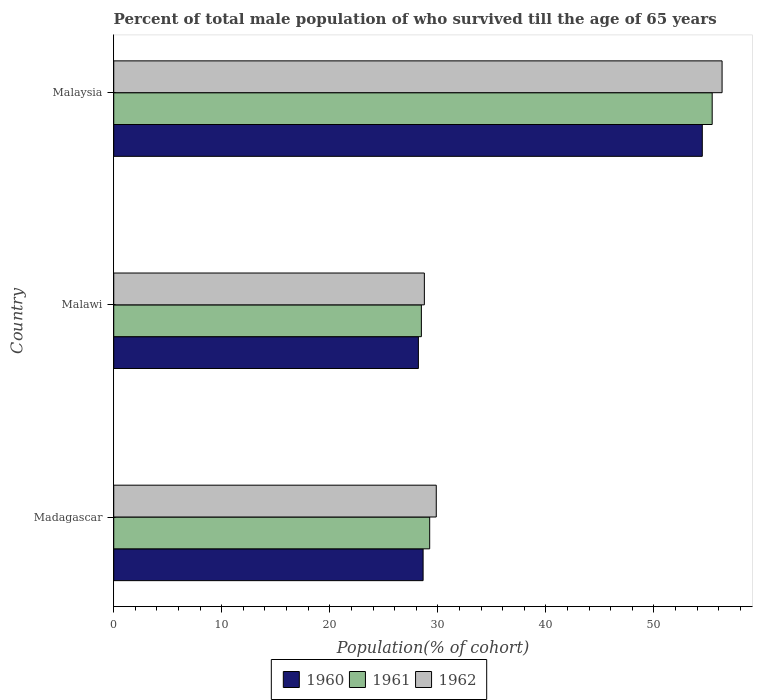How many different coloured bars are there?
Make the answer very short. 3. Are the number of bars on each tick of the Y-axis equal?
Provide a short and direct response. Yes. What is the label of the 3rd group of bars from the top?
Give a very brief answer. Madagascar. What is the percentage of total male population who survived till the age of 65 years in 1961 in Malaysia?
Ensure brevity in your answer.  55.4. Across all countries, what is the maximum percentage of total male population who survived till the age of 65 years in 1962?
Your response must be concise. 56.31. Across all countries, what is the minimum percentage of total male population who survived till the age of 65 years in 1960?
Your answer should be compact. 28.2. In which country was the percentage of total male population who survived till the age of 65 years in 1961 maximum?
Offer a terse response. Malaysia. In which country was the percentage of total male population who survived till the age of 65 years in 1961 minimum?
Your answer should be compact. Malawi. What is the total percentage of total male population who survived till the age of 65 years in 1960 in the graph?
Your answer should be compact. 111.32. What is the difference between the percentage of total male population who survived till the age of 65 years in 1961 in Malawi and that in Malaysia?
Offer a very short reply. -26.92. What is the difference between the percentage of total male population who survived till the age of 65 years in 1960 in Malawi and the percentage of total male population who survived till the age of 65 years in 1962 in Madagascar?
Keep it short and to the point. -1.65. What is the average percentage of total male population who survived till the age of 65 years in 1962 per country?
Provide a succinct answer. 38.31. What is the difference between the percentage of total male population who survived till the age of 65 years in 1960 and percentage of total male population who survived till the age of 65 years in 1961 in Madagascar?
Provide a short and direct response. -0.61. In how many countries, is the percentage of total male population who survived till the age of 65 years in 1962 greater than 12 %?
Give a very brief answer. 3. What is the ratio of the percentage of total male population who survived till the age of 65 years in 1960 in Madagascar to that in Malaysia?
Your response must be concise. 0.53. Is the percentage of total male population who survived till the age of 65 years in 1962 in Malawi less than that in Malaysia?
Ensure brevity in your answer.  Yes. Is the difference between the percentage of total male population who survived till the age of 65 years in 1960 in Madagascar and Malaysia greater than the difference between the percentage of total male population who survived till the age of 65 years in 1961 in Madagascar and Malaysia?
Provide a short and direct response. Yes. What is the difference between the highest and the second highest percentage of total male population who survived till the age of 65 years in 1961?
Offer a terse response. 26.15. What is the difference between the highest and the lowest percentage of total male population who survived till the age of 65 years in 1962?
Make the answer very short. 27.56. What does the 1st bar from the bottom in Malaysia represents?
Provide a short and direct response. 1960. How many bars are there?
Give a very brief answer. 9. What is the difference between two consecutive major ticks on the X-axis?
Offer a very short reply. 10. Are the values on the major ticks of X-axis written in scientific E-notation?
Keep it short and to the point. No. Does the graph contain any zero values?
Give a very brief answer. No. What is the title of the graph?
Your response must be concise. Percent of total male population of who survived till the age of 65 years. Does "1990" appear as one of the legend labels in the graph?
Keep it short and to the point. No. What is the label or title of the X-axis?
Offer a very short reply. Population(% of cohort). What is the label or title of the Y-axis?
Provide a short and direct response. Country. What is the Population(% of cohort) in 1960 in Madagascar?
Provide a succinct answer. 28.64. What is the Population(% of cohort) of 1961 in Madagascar?
Provide a succinct answer. 29.25. What is the Population(% of cohort) of 1962 in Madagascar?
Provide a short and direct response. 29.86. What is the Population(% of cohort) in 1960 in Malawi?
Offer a terse response. 28.2. What is the Population(% of cohort) in 1961 in Malawi?
Make the answer very short. 28.48. What is the Population(% of cohort) in 1962 in Malawi?
Provide a short and direct response. 28.75. What is the Population(% of cohort) of 1960 in Malaysia?
Your answer should be compact. 54.48. What is the Population(% of cohort) of 1961 in Malaysia?
Give a very brief answer. 55.4. What is the Population(% of cohort) of 1962 in Malaysia?
Your answer should be very brief. 56.31. Across all countries, what is the maximum Population(% of cohort) in 1960?
Your answer should be very brief. 54.48. Across all countries, what is the maximum Population(% of cohort) of 1961?
Provide a succinct answer. 55.4. Across all countries, what is the maximum Population(% of cohort) of 1962?
Offer a very short reply. 56.31. Across all countries, what is the minimum Population(% of cohort) of 1960?
Provide a succinct answer. 28.2. Across all countries, what is the minimum Population(% of cohort) of 1961?
Keep it short and to the point. 28.48. Across all countries, what is the minimum Population(% of cohort) of 1962?
Provide a short and direct response. 28.75. What is the total Population(% of cohort) of 1960 in the graph?
Make the answer very short. 111.32. What is the total Population(% of cohort) of 1961 in the graph?
Provide a short and direct response. 113.12. What is the total Population(% of cohort) in 1962 in the graph?
Your response must be concise. 114.92. What is the difference between the Population(% of cohort) of 1960 in Madagascar and that in Malawi?
Ensure brevity in your answer.  0.44. What is the difference between the Population(% of cohort) in 1961 in Madagascar and that in Malawi?
Provide a short and direct response. 0.77. What is the difference between the Population(% of cohort) in 1962 in Madagascar and that in Malawi?
Your answer should be compact. 1.1. What is the difference between the Population(% of cohort) in 1960 in Madagascar and that in Malaysia?
Keep it short and to the point. -25.84. What is the difference between the Population(% of cohort) in 1961 in Madagascar and that in Malaysia?
Offer a very short reply. -26.15. What is the difference between the Population(% of cohort) of 1962 in Madagascar and that in Malaysia?
Your answer should be compact. -26.46. What is the difference between the Population(% of cohort) of 1960 in Malawi and that in Malaysia?
Your response must be concise. -26.28. What is the difference between the Population(% of cohort) in 1961 in Malawi and that in Malaysia?
Provide a succinct answer. -26.92. What is the difference between the Population(% of cohort) of 1962 in Malawi and that in Malaysia?
Keep it short and to the point. -27.56. What is the difference between the Population(% of cohort) of 1960 in Madagascar and the Population(% of cohort) of 1961 in Malawi?
Offer a terse response. 0.16. What is the difference between the Population(% of cohort) in 1960 in Madagascar and the Population(% of cohort) in 1962 in Malawi?
Ensure brevity in your answer.  -0.12. What is the difference between the Population(% of cohort) in 1961 in Madagascar and the Population(% of cohort) in 1962 in Malawi?
Offer a terse response. 0.49. What is the difference between the Population(% of cohort) of 1960 in Madagascar and the Population(% of cohort) of 1961 in Malaysia?
Your answer should be very brief. -26.76. What is the difference between the Population(% of cohort) of 1960 in Madagascar and the Population(% of cohort) of 1962 in Malaysia?
Provide a short and direct response. -27.67. What is the difference between the Population(% of cohort) of 1961 in Madagascar and the Population(% of cohort) of 1962 in Malaysia?
Give a very brief answer. -27.07. What is the difference between the Population(% of cohort) of 1960 in Malawi and the Population(% of cohort) of 1961 in Malaysia?
Provide a succinct answer. -27.2. What is the difference between the Population(% of cohort) of 1960 in Malawi and the Population(% of cohort) of 1962 in Malaysia?
Your answer should be compact. -28.11. What is the difference between the Population(% of cohort) in 1961 in Malawi and the Population(% of cohort) in 1962 in Malaysia?
Provide a succinct answer. -27.84. What is the average Population(% of cohort) of 1960 per country?
Your response must be concise. 37.11. What is the average Population(% of cohort) of 1961 per country?
Make the answer very short. 37.71. What is the average Population(% of cohort) in 1962 per country?
Your answer should be very brief. 38.31. What is the difference between the Population(% of cohort) in 1960 and Population(% of cohort) in 1961 in Madagascar?
Keep it short and to the point. -0.61. What is the difference between the Population(% of cohort) in 1960 and Population(% of cohort) in 1962 in Madagascar?
Ensure brevity in your answer.  -1.22. What is the difference between the Population(% of cohort) of 1961 and Population(% of cohort) of 1962 in Madagascar?
Provide a short and direct response. -0.61. What is the difference between the Population(% of cohort) in 1960 and Population(% of cohort) in 1961 in Malawi?
Offer a terse response. -0.28. What is the difference between the Population(% of cohort) of 1960 and Population(% of cohort) of 1962 in Malawi?
Your response must be concise. -0.55. What is the difference between the Population(% of cohort) in 1961 and Population(% of cohort) in 1962 in Malawi?
Keep it short and to the point. -0.28. What is the difference between the Population(% of cohort) in 1960 and Population(% of cohort) in 1961 in Malaysia?
Give a very brief answer. -0.92. What is the difference between the Population(% of cohort) of 1960 and Population(% of cohort) of 1962 in Malaysia?
Ensure brevity in your answer.  -1.83. What is the difference between the Population(% of cohort) of 1961 and Population(% of cohort) of 1962 in Malaysia?
Keep it short and to the point. -0.92. What is the ratio of the Population(% of cohort) in 1960 in Madagascar to that in Malawi?
Make the answer very short. 1.02. What is the ratio of the Population(% of cohort) of 1962 in Madagascar to that in Malawi?
Provide a succinct answer. 1.04. What is the ratio of the Population(% of cohort) of 1960 in Madagascar to that in Malaysia?
Offer a terse response. 0.53. What is the ratio of the Population(% of cohort) of 1961 in Madagascar to that in Malaysia?
Your answer should be very brief. 0.53. What is the ratio of the Population(% of cohort) of 1962 in Madagascar to that in Malaysia?
Give a very brief answer. 0.53. What is the ratio of the Population(% of cohort) of 1960 in Malawi to that in Malaysia?
Provide a succinct answer. 0.52. What is the ratio of the Population(% of cohort) in 1961 in Malawi to that in Malaysia?
Your answer should be very brief. 0.51. What is the ratio of the Population(% of cohort) in 1962 in Malawi to that in Malaysia?
Provide a succinct answer. 0.51. What is the difference between the highest and the second highest Population(% of cohort) of 1960?
Offer a terse response. 25.84. What is the difference between the highest and the second highest Population(% of cohort) in 1961?
Provide a short and direct response. 26.15. What is the difference between the highest and the second highest Population(% of cohort) in 1962?
Your answer should be very brief. 26.46. What is the difference between the highest and the lowest Population(% of cohort) of 1960?
Make the answer very short. 26.28. What is the difference between the highest and the lowest Population(% of cohort) of 1961?
Offer a terse response. 26.92. What is the difference between the highest and the lowest Population(% of cohort) of 1962?
Keep it short and to the point. 27.56. 